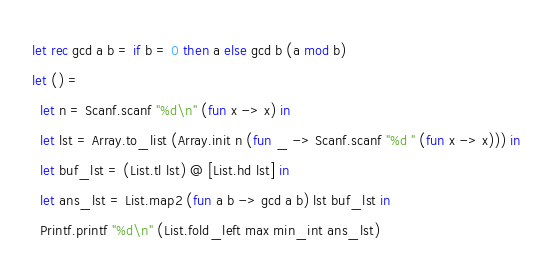<code> <loc_0><loc_0><loc_500><loc_500><_OCaml_>let rec gcd a b = if b = 0 then a else gcd b (a mod b)
let () =
  let n = Scanf.scanf "%d\n" (fun x -> x) in
  let lst = Array.to_list (Array.init n (fun _ -> Scanf.scanf "%d " (fun x -> x))) in
  let buf_lst = (List.tl lst) @ [List.hd lst] in
  let ans_lst = List.map2 (fun a b -> gcd a b) lst buf_lst in
  Printf.printf "%d\n" (List.fold_left max min_int ans_lst)
</code> 